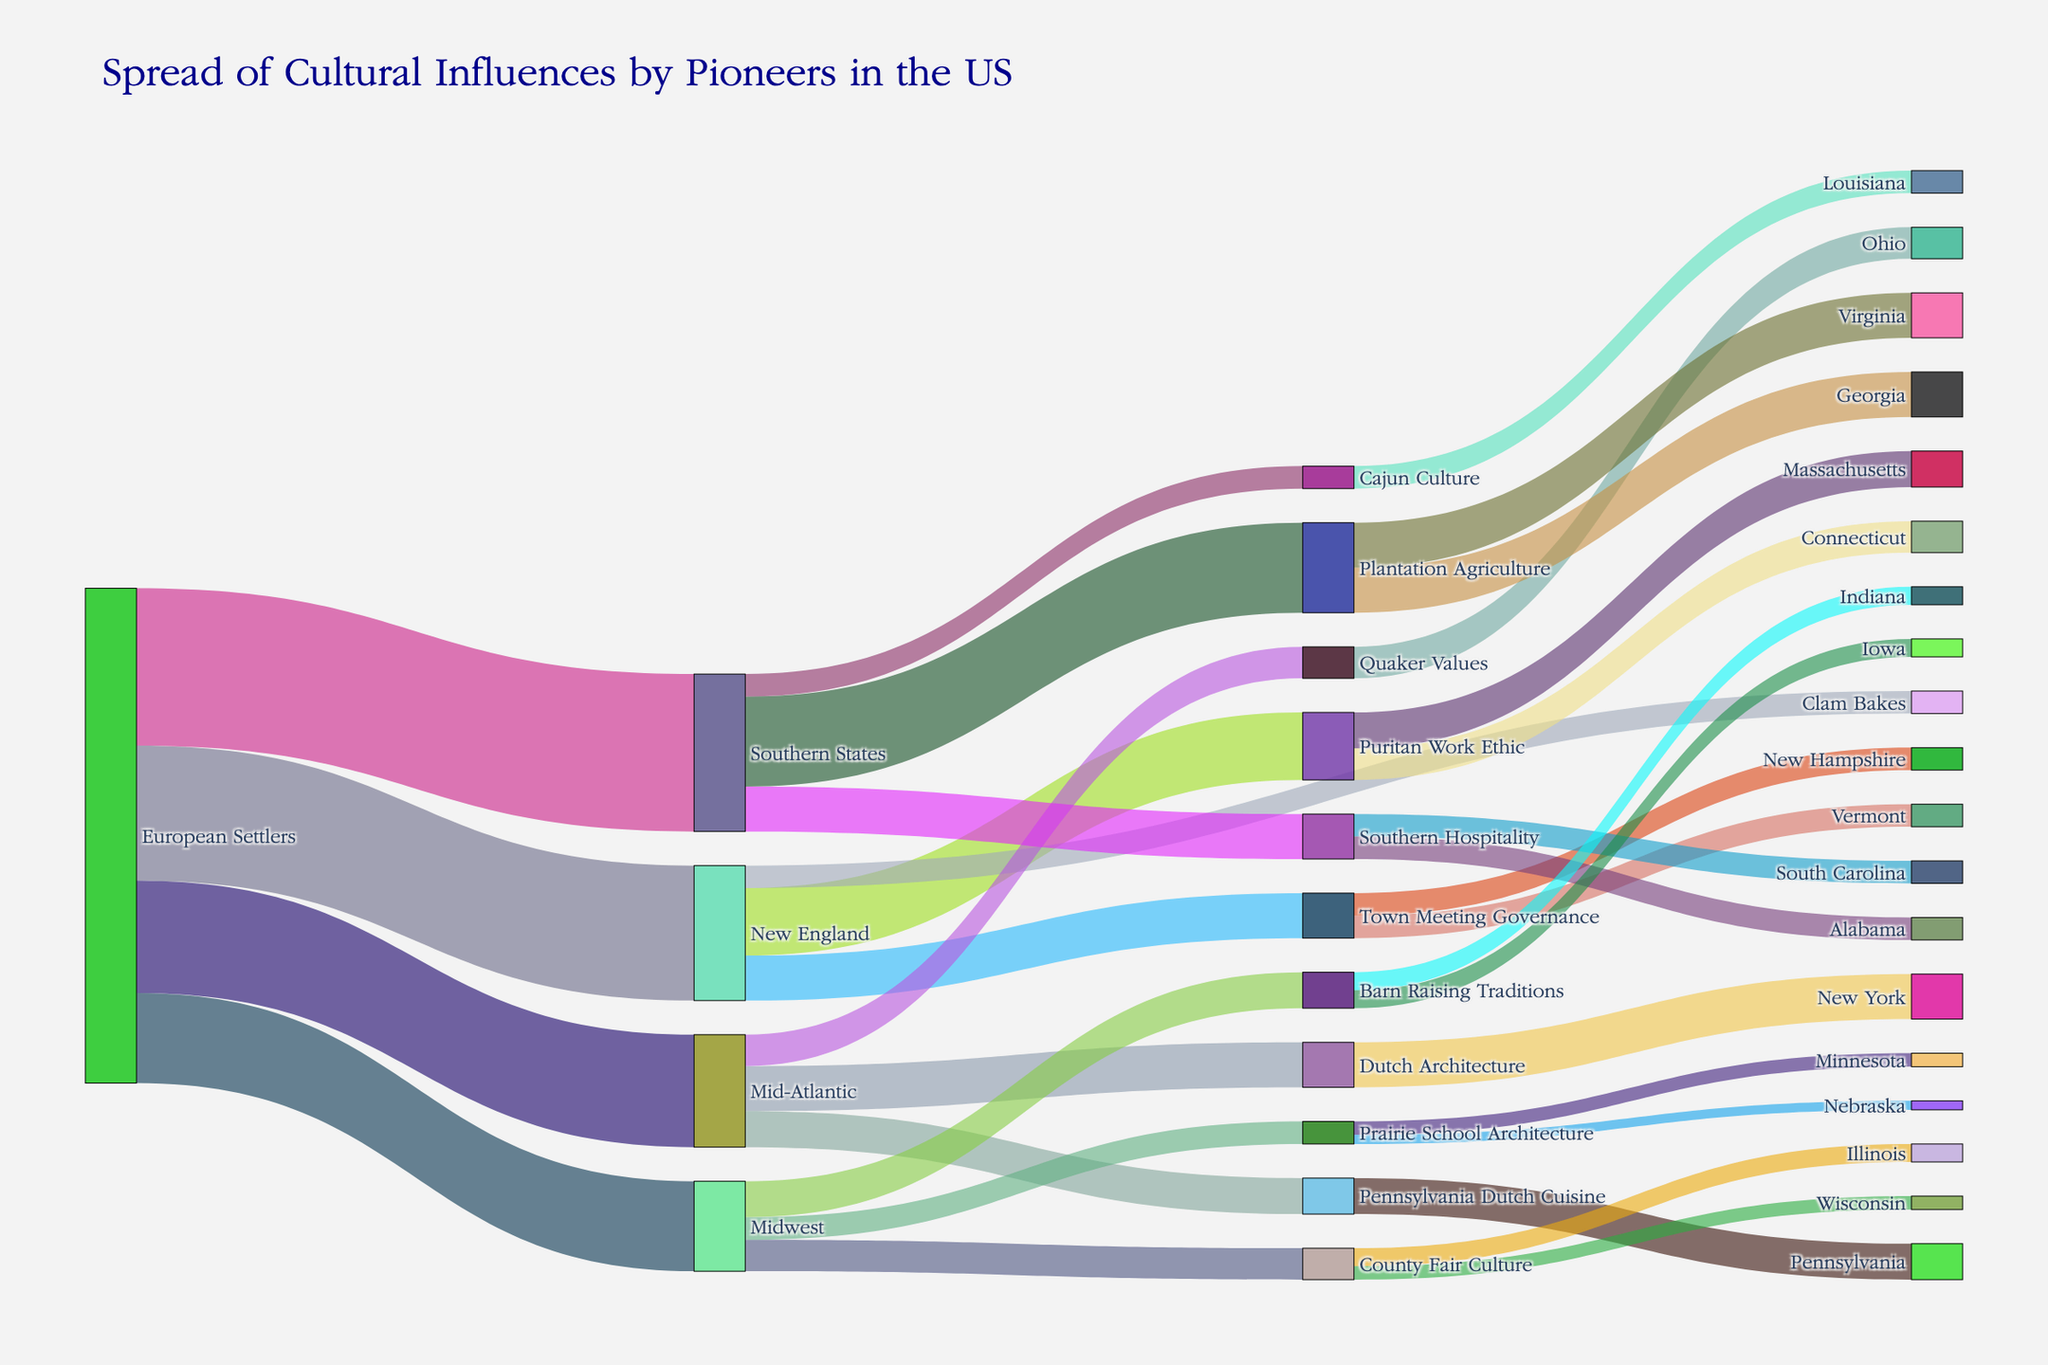What is the title of the figure? The title of the figure is usually located at the top and provides a quick understanding of the content. From the provided code, the title is set to "Spread of Cultural Influences by Pioneers in the US"
Answer: Spread of Cultural Influences by Pioneers in the US Which source group contributed the most cultural influences? By evaluating the figure, we determine which source group has the highest combined value of connections leading to various targets. From the data, "European Settlers" has the highest combined contribution values (30 + 25 + 35 + 20 = 110) compared to other groups.
Answer: European Settlers What was the value of cultural influences brought by European Settlers to the Mid-Atlantic states? Locate the "European Settlers" node and trace the connecting link to the "Mid-Atlantic" target. The link shows the value of cultural influence contributed, which is 25.
Answer: 25 How many cultural influences were brought to Georgia from pioneer groups? Identify the "Georgia" node and trace back through its links to the source cultural influences. From the data, Georgia receives 10 from "Plantation Agriculture". Thus, one significant cultural influence reaches Georgia but with a total value of 10.
Answer: 10 What is the combined influence of Puritan Work Ethic in Massachusetts and Connecticut? Find the links from "Puritan Work Ethic" to "Massachusetts" and "Connecticut". The values for these links are 8 and 7, respectively. Adding these gives 8 + 7 = 15.
Answer: 15 Compare the cultural influence values of Southern Hospitality in South Carolina and Alabama. Which state received more influence? Locate the links from "Southern Hospitality" to "South Carolina" and "Alabama". The values are both 5. Since they are equal, neither state received more influence.
Answer: Both received equal influence Which target has the smallest value of cultural influence from European Settlers? By analyzing the values for each link from "European Settlers" to different targets (New England, Mid-Atlantic, Southern States, Midwest), the smallest value is 20, which connects to "Midwest".
Answer: Midwest Which state has been influenced by Cajun Culture? Trace the link from "Cajun Culture" to its corresponding state. From the data and diagram, the link leads to Louisiana.
Answer: Louisiana What are the three cultural influences that come from the Southern States? Track the links from the "Southern States" to their cultural influences. The links point to "Plantation Agriculture" (20), "Southern Hospitality" (10), and "Cajun Culture" (5).
Answer: Plantation Agriculture, Southern Hospitality, Cajun Culture How many total cultural influences originated from the Mid-Atlantic region? Sum the values of the links originating from "Mid-Atlantic" to its cultural influences: Dutch Architecture (10), Pennsylvania Dutch Cuisine (8), Quaker Values (7). The total is 10 + 8 + 7 = 25.
Answer: 25 